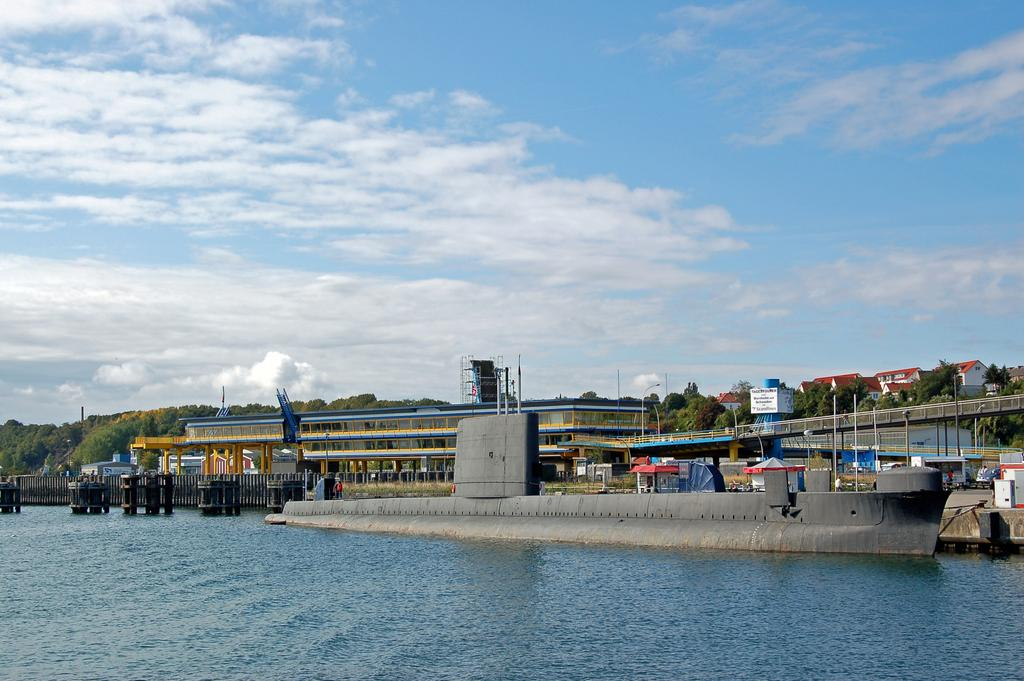What is located in the center of the image? Buildings, street lights, pillars, and trees are located in the center of the image. What type of structure can be seen in the image? A ship is present in the image. What is visible in the background of the image? The sky is visible in the image, with clouds present. What is at the bottom of the image? There is water at the bottom of the image. What type of bit is being used by the machine in the image? There is no machine or bit present in the image. Can you make a comparison between the size of the trees and the ship in the image? It is not possible to make a comparison between the size of the trees and the ship in the image, as the provided facts do not include any information about their relative sizes. 